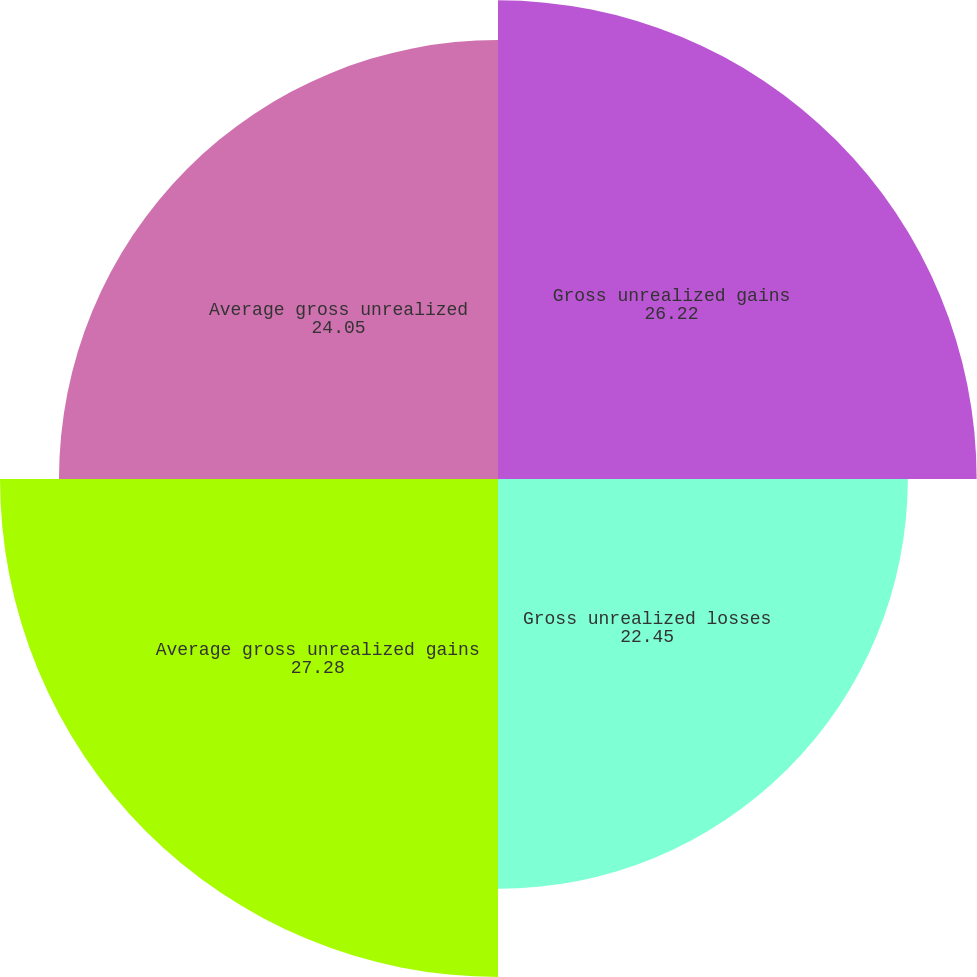<chart> <loc_0><loc_0><loc_500><loc_500><pie_chart><fcel>Gross unrealized gains<fcel>Gross unrealized losses<fcel>Average gross unrealized gains<fcel>Average gross unrealized<nl><fcel>26.22%<fcel>22.45%<fcel>27.28%<fcel>24.05%<nl></chart> 